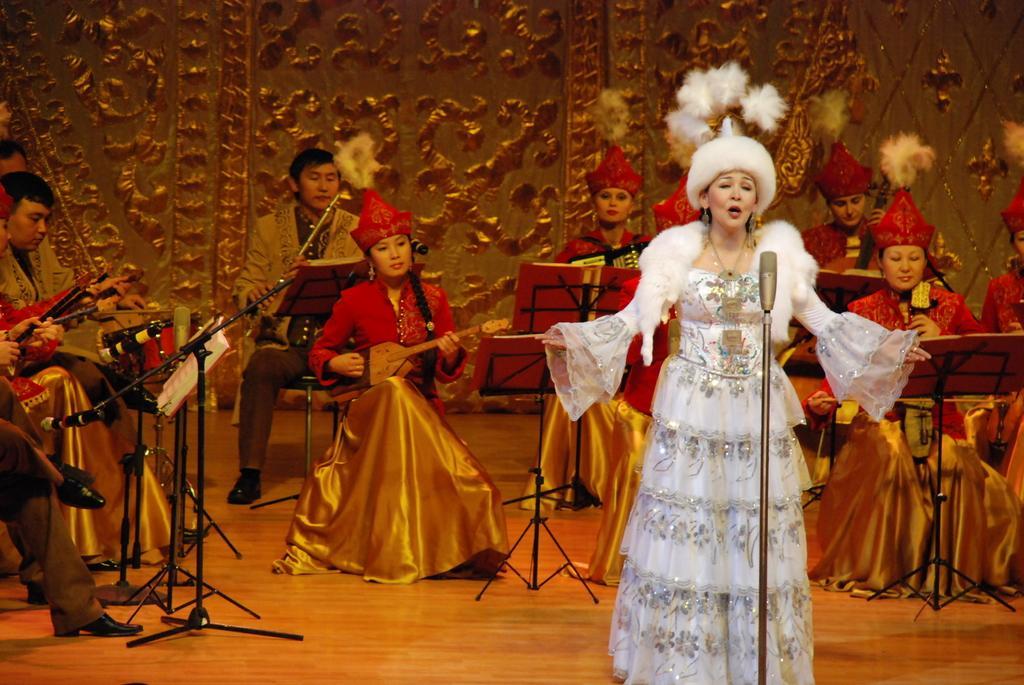How would you summarize this image in a sentence or two? In this image I can see number of people where one is standing and rest all are sitting. I can also see except one, everyone are holding musical instruments. I can also see few mice and few stands. 